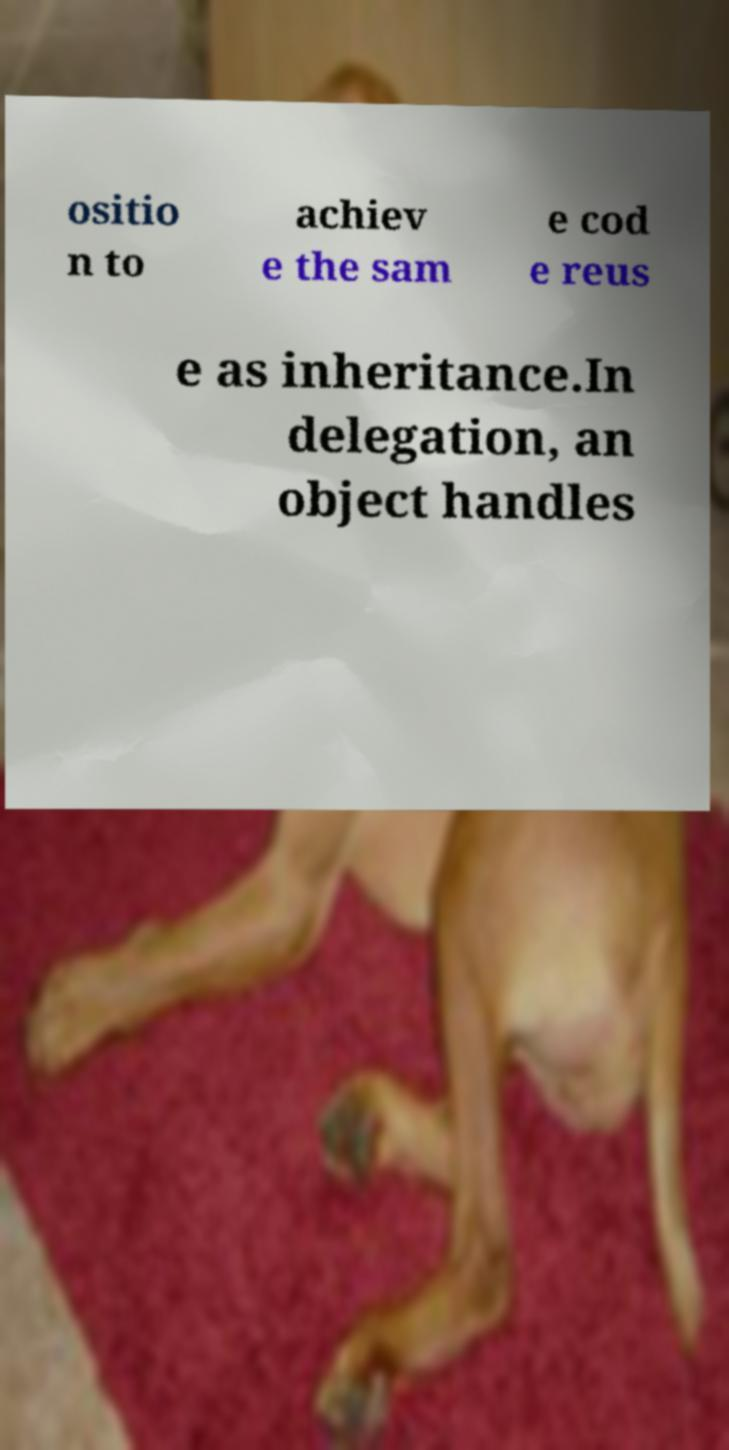Can you read and provide the text displayed in the image?This photo seems to have some interesting text. Can you extract and type it out for me? ositio n to achiev e the sam e cod e reus e as inheritance.In delegation, an object handles 